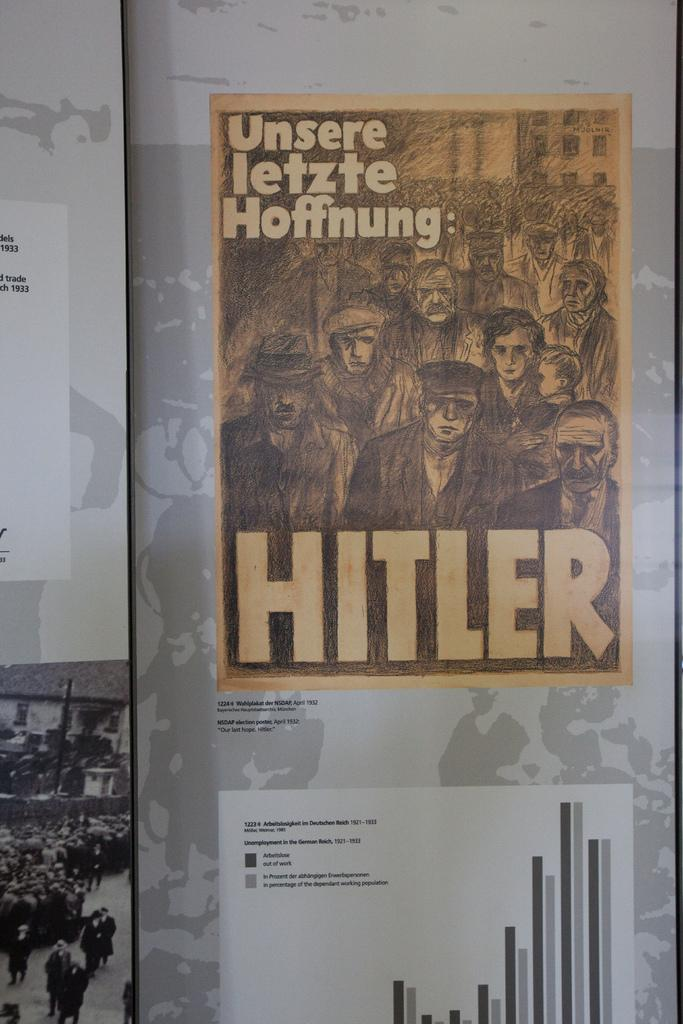<image>
Share a concise interpretation of the image provided. A reproduction of a poster about Hitler features shadowy figures. 